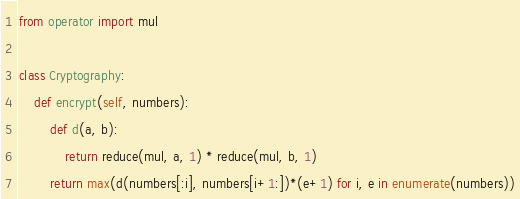Convert code to text. <code><loc_0><loc_0><loc_500><loc_500><_Python_>from operator import mul

class Cryptography:
    def encrypt(self, numbers):
        def d(a, b):
            return reduce(mul, a, 1) * reduce(mul, b, 1)
        return max(d(numbers[:i], numbers[i+1:])*(e+1) for i, e in enumerate(numbers))
</code> 